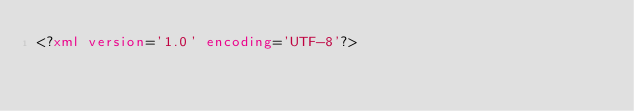<code> <loc_0><loc_0><loc_500><loc_500><_XML_><?xml version='1.0' encoding='UTF-8'?></code> 